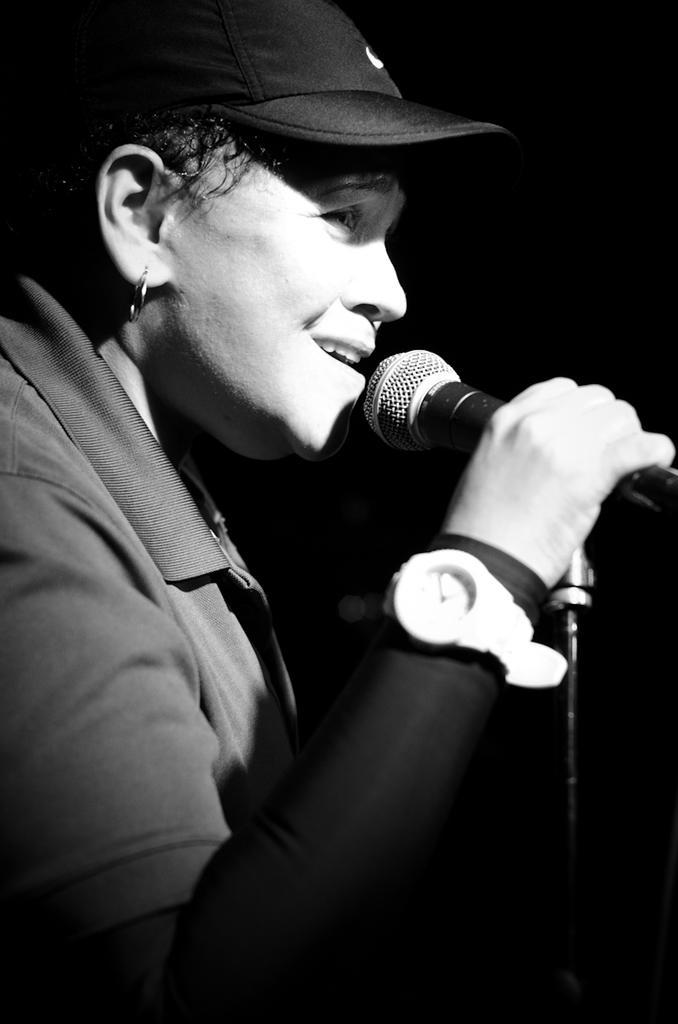Describe this image in one or two sentences. It is a black and white image. In this image there is a person holding the mike. 